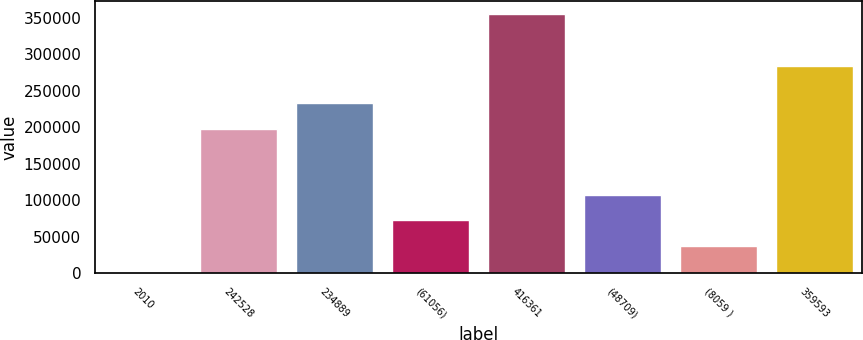<chart> <loc_0><loc_0><loc_500><loc_500><bar_chart><fcel>2010<fcel>242528<fcel>234889<fcel>(61056)<fcel>416361<fcel>(48709)<fcel>(8059 )<fcel>359593<nl><fcel>2008<fcel>197838<fcel>233150<fcel>72633<fcel>355133<fcel>107946<fcel>37320.5<fcel>283922<nl></chart> 